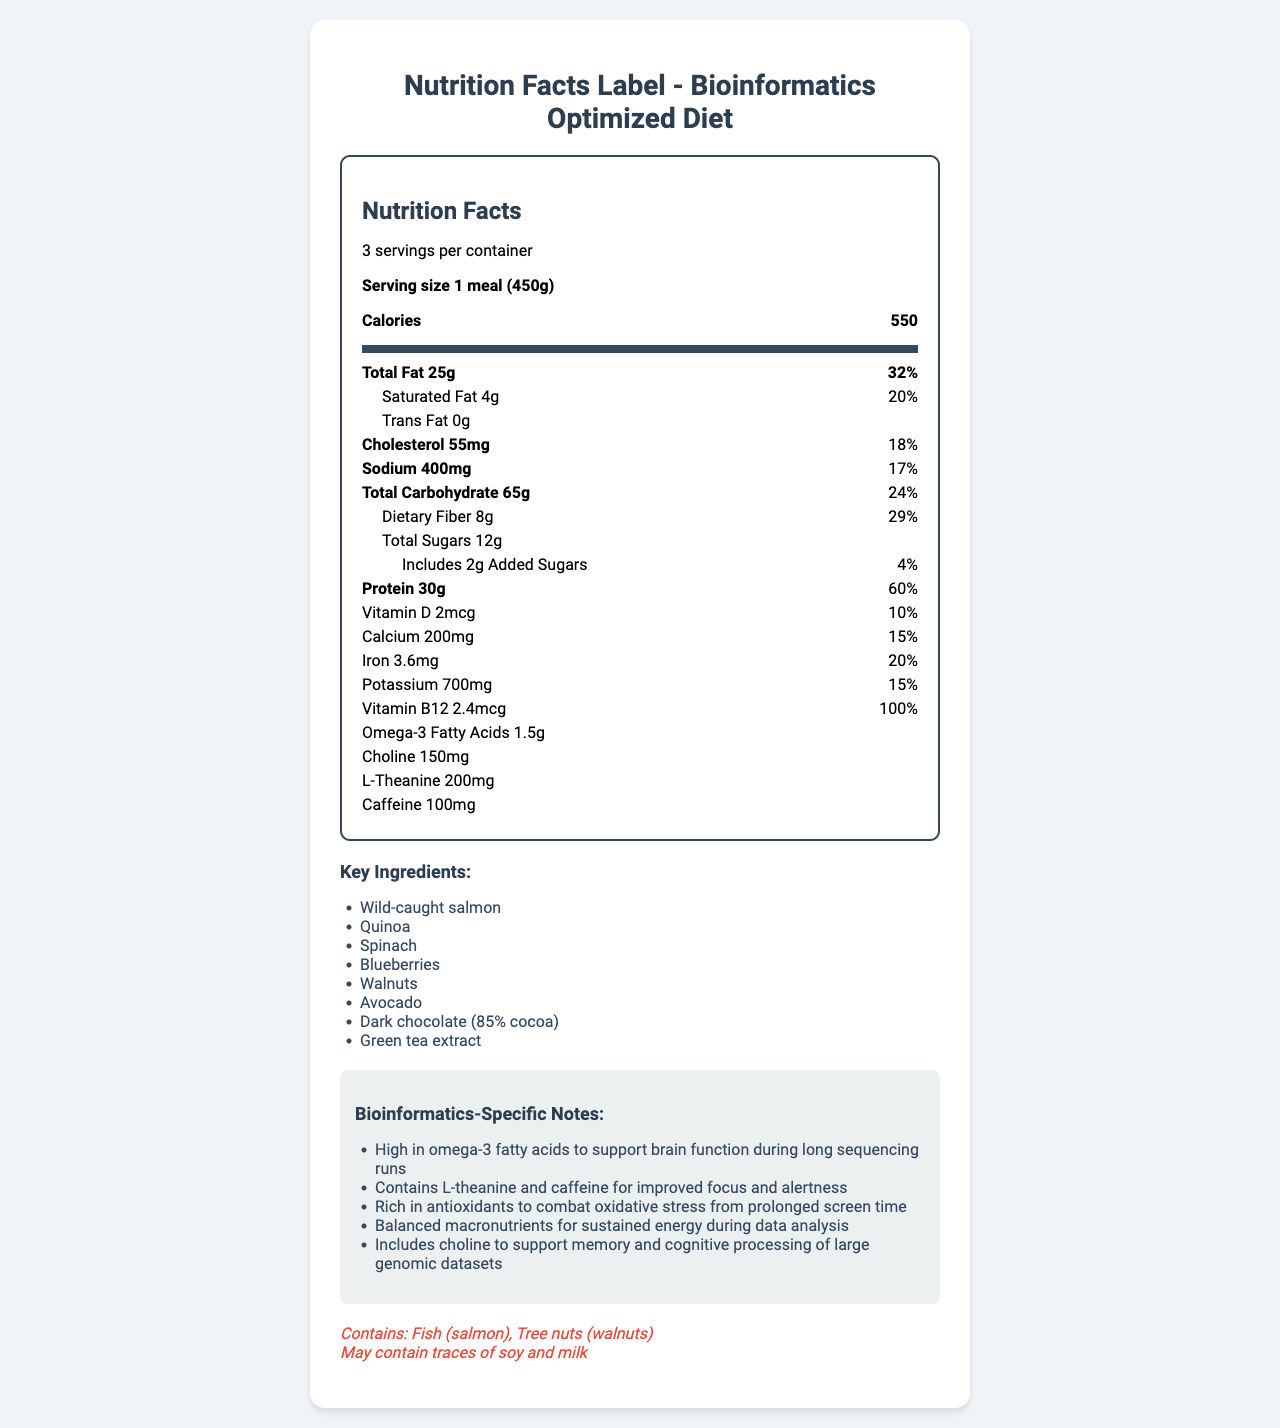What is the serving size for this diet? The serving size is clearly indicated as "1 meal (450g)" at the beginning of the Nutrition Facts section.
Answer: 1 meal (450g) How many servings are in one container? The label states that there are "3 servings per container".
Answer: 3 What is the total carbohydrate content per serving? Under the Nutrition Facts, the total carbohydrate content is listed as "65g".
Answer: 65g How much protein does one serving contain? The amount of protein per serving is listed as "30g".
Answer: 30g How many calories are in a single serving? The document clearly states that each serving has "550 calories".
Answer: 550 Which ingredient provides cognitive benefits during long sequencing runs? A. Quinoa B. Blueberries C. Wild-caught salmon D. Green tea extract The bioinformatics-specific notes mention that the "diet contains L-theanine and caffeine for improved focus and alertness", which is associated with Green tea extract.
Answer: D What are the added sugars content in one serving, in percentage of daily value? A. 4% B. 10% C. 1% D. 6% The added sugars content is listed as "2g" which corresponds to "4% of daily value".
Answer: A Does this nutrition label indicate the presence of iron? Iron is listed in the Nutrition Facts section as "3.6mg", which is 20% of the daily value.
Answer: Yes Provide a summary of the nutrition label. This summary describes the overall content and purpose of the dietary label, which is to optimize cognitive performance for bioinformatics professionals, along with key details about its composition.
Answer: This nutrition label describes the nutritional breakdown of a specialized diet optimized for cognitive performance with key ingredients like wild-caught salmon, quinoa, spinach, and blueberries. It contains 550 calories per 450g serving with significant amounts of protein (30g), total fat (25g), and carbohydrates (65g). It is tailored for bioinformatics professionals, containing L-theanine and caffeine for focus, and is rich in omega-3 fatty acids, antioxidants, and choline. It warns against allergens like fish and tree nuts. Does this diet contain milk allergens? The allergen section states "May contain traces of soy and milk" without confirming definite presence.
Answer: Not enough information How much L-theanine is present in one serving? The Nutrition Facts section lists the L-theanine content as "200mg".
Answer: 200mg What are the key ingredients highlighted in this diet? The ingredients are listed under the "Key Ingredients" section.
Answer: Wild-caught salmon, Quinoa, Spinach, Blueberries, Walnuts, Avocado, Dark chocolate (85% cocoa), Green tea extract What is the total daily value percentage of cholesterol in one serving? The percentage daily value for cholesterol is given as "18%" in the Nutrition Facts section.
Answer: 18% How much dietary fiber does this meal provide per serving? The dietary fiber content per serving is given as "8g".
Answer: 8g Which nutrient in this diet supports brain function during long sequencing runs? The bioinformatics-specific notes mention the diet is "High in omega-3 fatty acids to support brain function during long sequencing runs".
Answer: Omega-3 fatty acids 